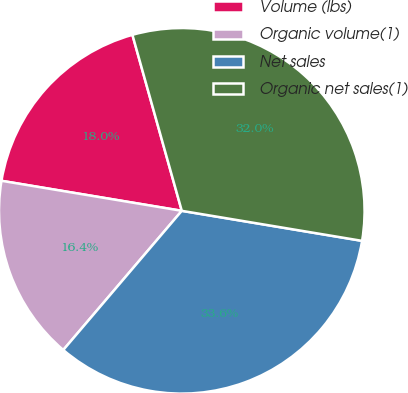Convert chart. <chart><loc_0><loc_0><loc_500><loc_500><pie_chart><fcel>Volume (lbs)<fcel>Organic volume(1)<fcel>Net sales<fcel>Organic net sales(1)<nl><fcel>18.02%<fcel>16.4%<fcel>33.6%<fcel>31.98%<nl></chart> 